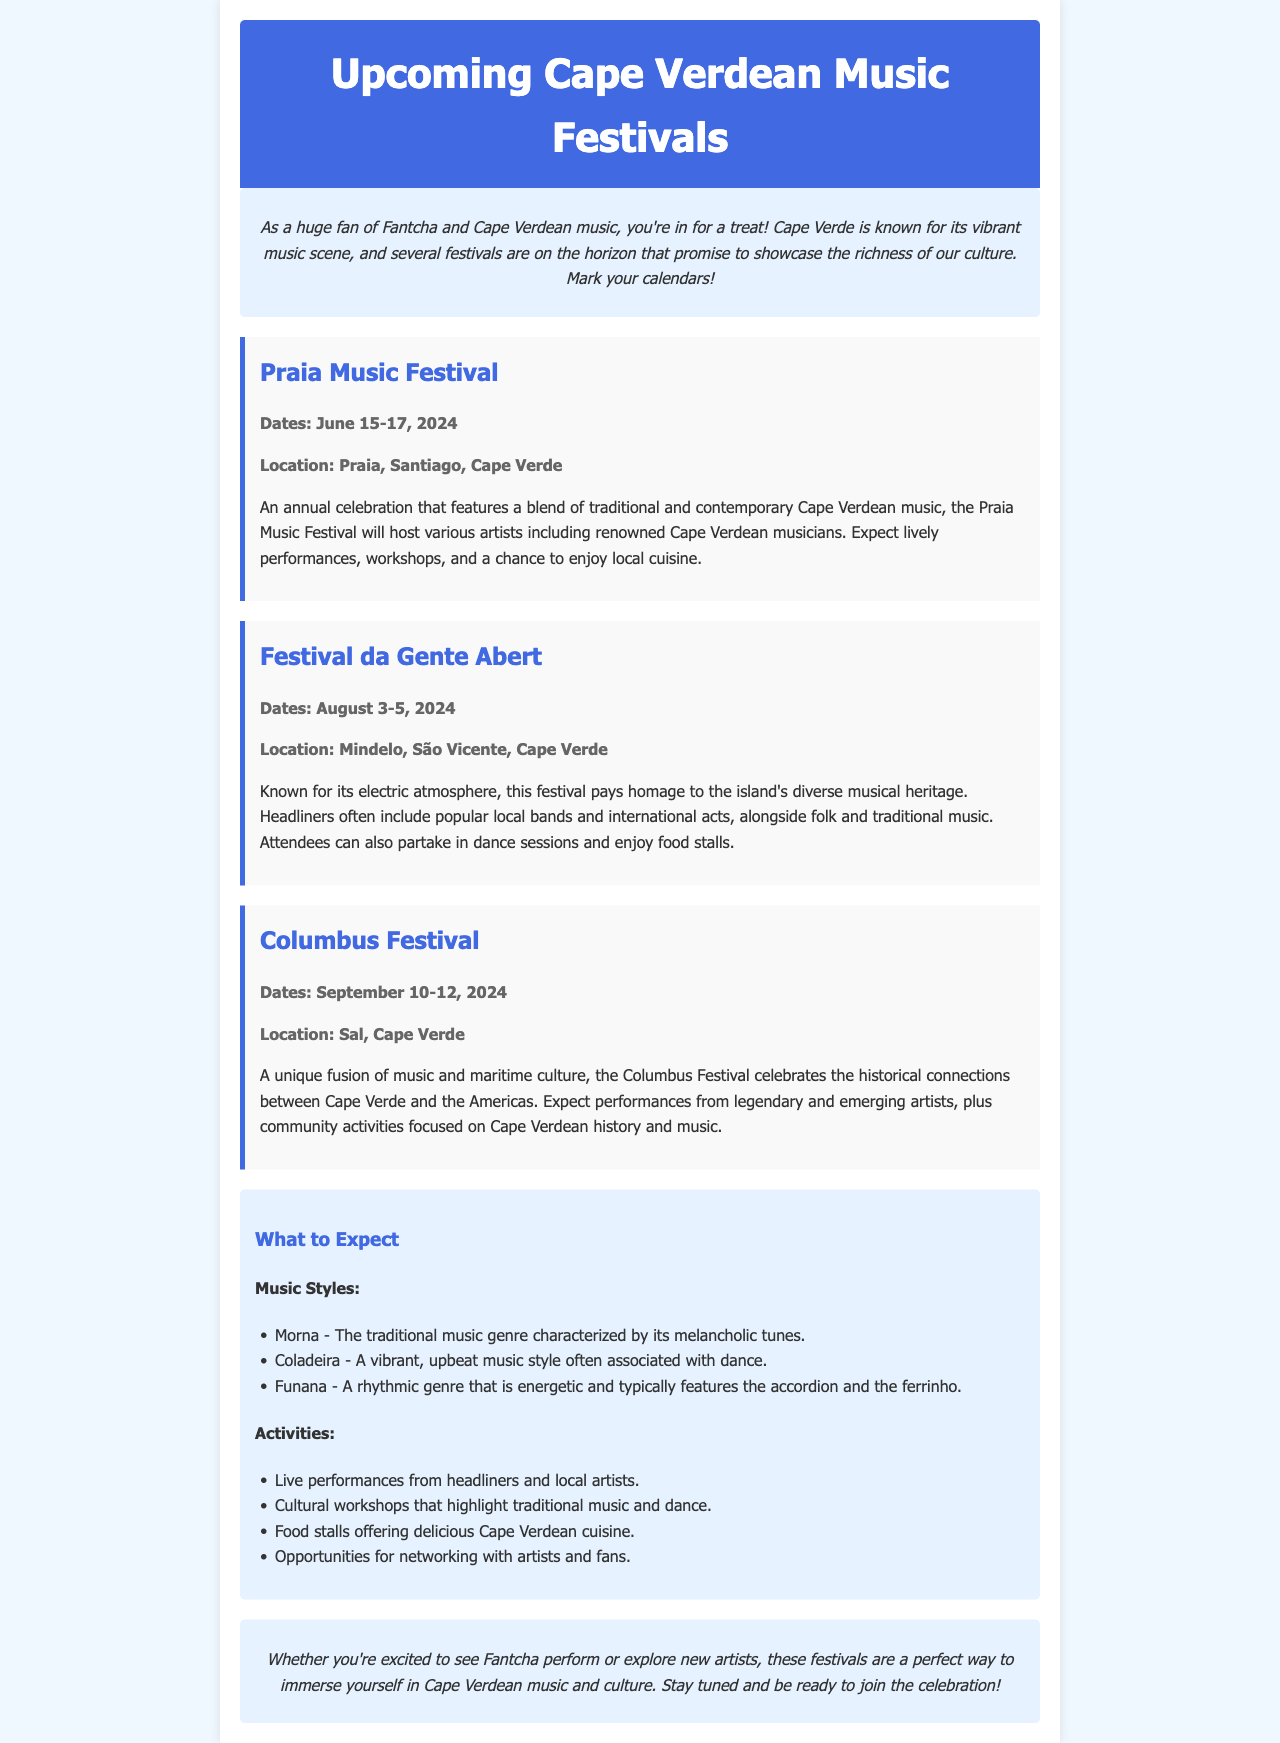What are the dates of the Praia Music Festival? The dates are specifically mentioned in the festival section for Praia Music Festival as June 15-17, 2024.
Answer: June 15-17, 2024 Where is the Festival da Gente Abert held? The location of the Festival da Gente Abert is explicitly stated as Mindelo, São Vicente, Cape Verde.
Answer: Mindelo, São Vicente, Cape Verde What type of music is characteristic of Morna? The document describes Morna as the traditional music genre characterized by its melancholic tunes.
Answer: Melancholic tunes Which festival focuses on maritime culture? The Columbus Festival is mentioned in the document as celebrating the historical connections between Cape Verde and the Americas, which includes a maritime culture aspect.
Answer: Columbus Festival What activities can attendees expect at the festivals? The document lists various activities such as live performances, cultural workshops, food stalls, and networking opportunities.
Answer: Live performances, cultural workshops, food stalls, networking What is the main theme of the upcoming festivals? The overarching theme includes showcasing the richness of Cape Verdean culture and music, as indicated in the introduction.
Answer: Richness of Cape Verdean culture and music Which festival takes place in Sal? The Columbus Festival is specifically stated to be held in Sal, Cape Verde according to the festival section.
Answer: Columbus Festival What are the expected music styles highlighted in the document? The document lists three music styles: Morna, Coladeira, and Funana, as the expected music styles at the festivals.
Answer: Morna, Coladeira, Funana 